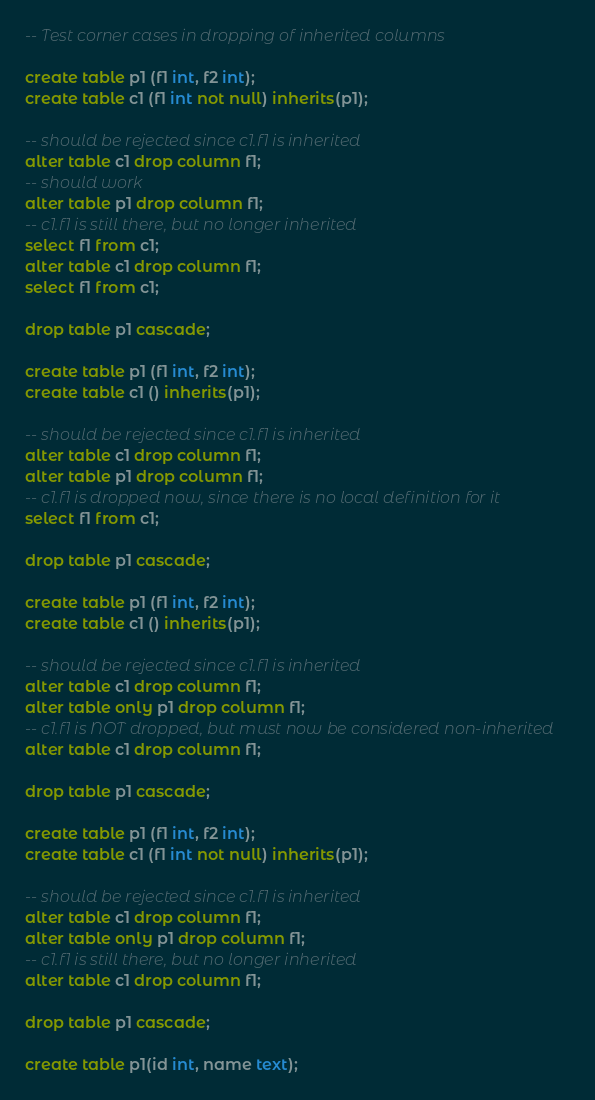Convert code to text. <code><loc_0><loc_0><loc_500><loc_500><_SQL_>

-- Test corner cases in dropping of inherited columns

create table p1 (f1 int, f2 int);
create table c1 (f1 int not null) inherits(p1);

-- should be rejected since c1.f1 is inherited
alter table c1 drop column f1;
-- should work
alter table p1 drop column f1;
-- c1.f1 is still there, but no longer inherited
select f1 from c1;
alter table c1 drop column f1;
select f1 from c1;

drop table p1 cascade;

create table p1 (f1 int, f2 int);
create table c1 () inherits(p1);

-- should be rejected since c1.f1 is inherited
alter table c1 drop column f1;
alter table p1 drop column f1;
-- c1.f1 is dropped now, since there is no local definition for it
select f1 from c1;

drop table p1 cascade;

create table p1 (f1 int, f2 int);
create table c1 () inherits(p1);

-- should be rejected since c1.f1 is inherited
alter table c1 drop column f1;
alter table only p1 drop column f1;
-- c1.f1 is NOT dropped, but must now be considered non-inherited
alter table c1 drop column f1;

drop table p1 cascade;

create table p1 (f1 int, f2 int);
create table c1 (f1 int not null) inherits(p1);

-- should be rejected since c1.f1 is inherited
alter table c1 drop column f1;
alter table only p1 drop column f1;
-- c1.f1 is still there, but no longer inherited
alter table c1 drop column f1;

drop table p1 cascade;

create table p1(id int, name text);</code> 